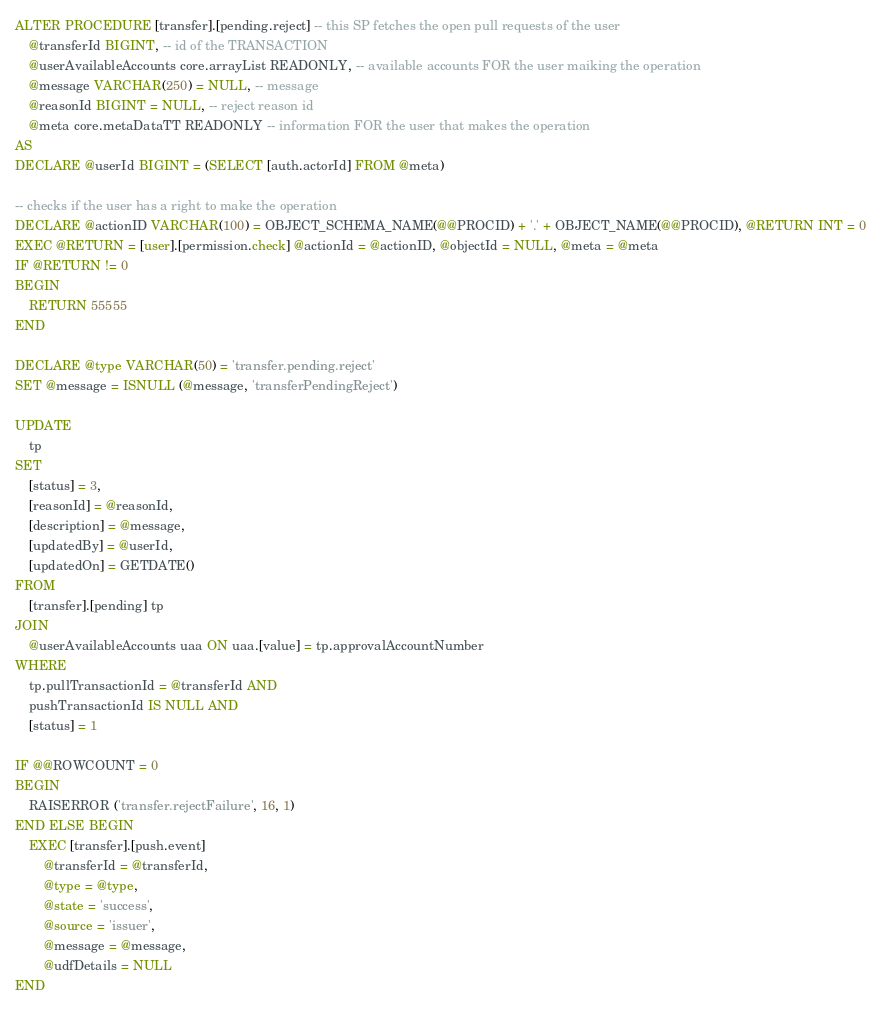Convert code to text. <code><loc_0><loc_0><loc_500><loc_500><_SQL_>ALTER PROCEDURE [transfer].[pending.reject] -- this SP fetches the open pull requests of the user
    @transferId BIGINT, -- id of the TRANSACTION
    @userAvailableAccounts core.arrayList READONLY, -- available accounts FOR the user maiking the operation
    @message VARCHAR(250) = NULL, -- message
    @reasonId BIGINT = NULL, -- reject reason id
    @meta core.metaDataTT READONLY -- information FOR the user that makes the operation
AS
DECLARE @userId BIGINT = (SELECT [auth.actorId] FROM @meta)

-- checks if the user has a right to make the operation
DECLARE @actionID VARCHAR(100) = OBJECT_SCHEMA_NAME(@@PROCID) + '.' + OBJECT_NAME(@@PROCID), @RETURN INT = 0
EXEC @RETURN = [user].[permission.check] @actionId = @actionID, @objectId = NULL, @meta = @meta
IF @RETURN != 0
BEGIN
    RETURN 55555
END

DECLARE @type VARCHAR(50) = 'transfer.pending.reject'
SET @message = ISNULL (@message, 'transferPendingReject')

UPDATE
    tp
SET
    [status] = 3,
    [reasonId] = @reasonId,
    [description] = @message,
    [updatedBy] = @userId,
    [updatedOn] = GETDATE()
FROM
    [transfer].[pending] tp
JOIN
    @userAvailableAccounts uaa ON uaa.[value] = tp.approvalAccountNumber
WHERE
    tp.pullTransactionId = @transferId AND
    pushTransactionId IS NULL AND
    [status] = 1

IF @@ROWCOUNT = 0
BEGIN
    RAISERROR ('transfer.rejectFailure', 16, 1)
END ELSE BEGIN
    EXEC [transfer].[push.event]
        @transferId = @transferId,
        @type = @type,
        @state = 'success',
        @source = 'issuer',
        @message = @message,
        @udfDetails = NULL
END
</code> 